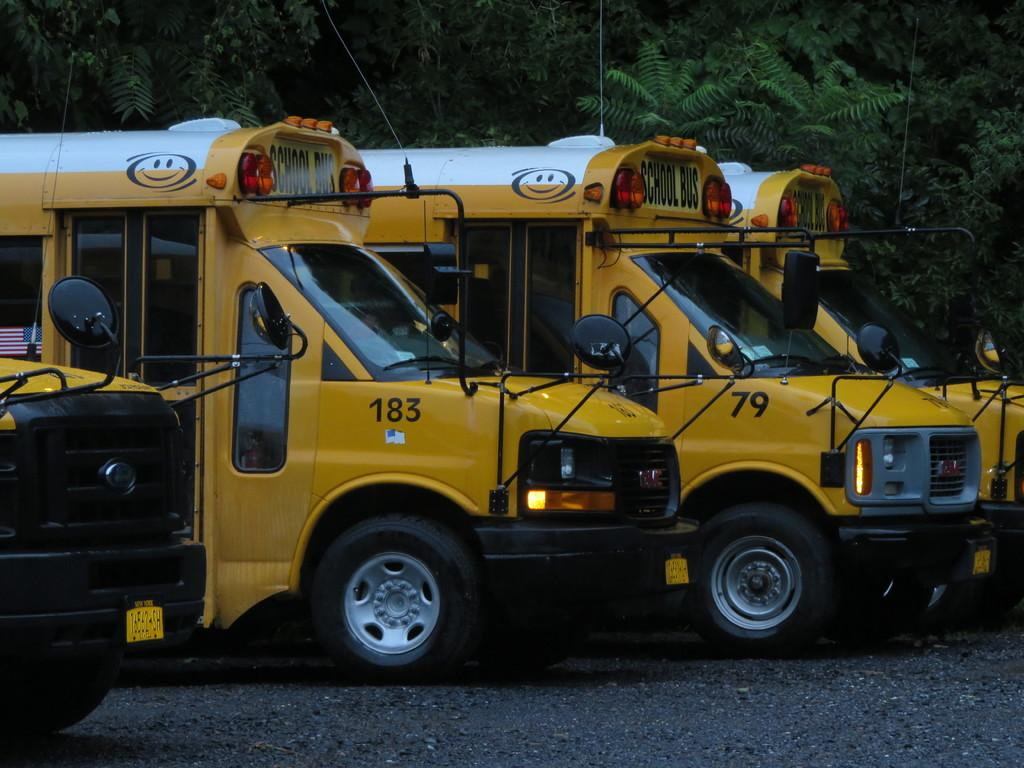What can be seen in the background of the image? There are trees in the background of the image. What is parked on the road in the image? There are school buses parked on the road in the image. What impulse can be seen affecting the school buses in the image? There is no impulse affecting the school buses in the image; they are parked and stationary. What time of day is it in the image, considering the presence of school buses? The time of day cannot be determined from the image alone, as school buses can be present at various times of the day. 